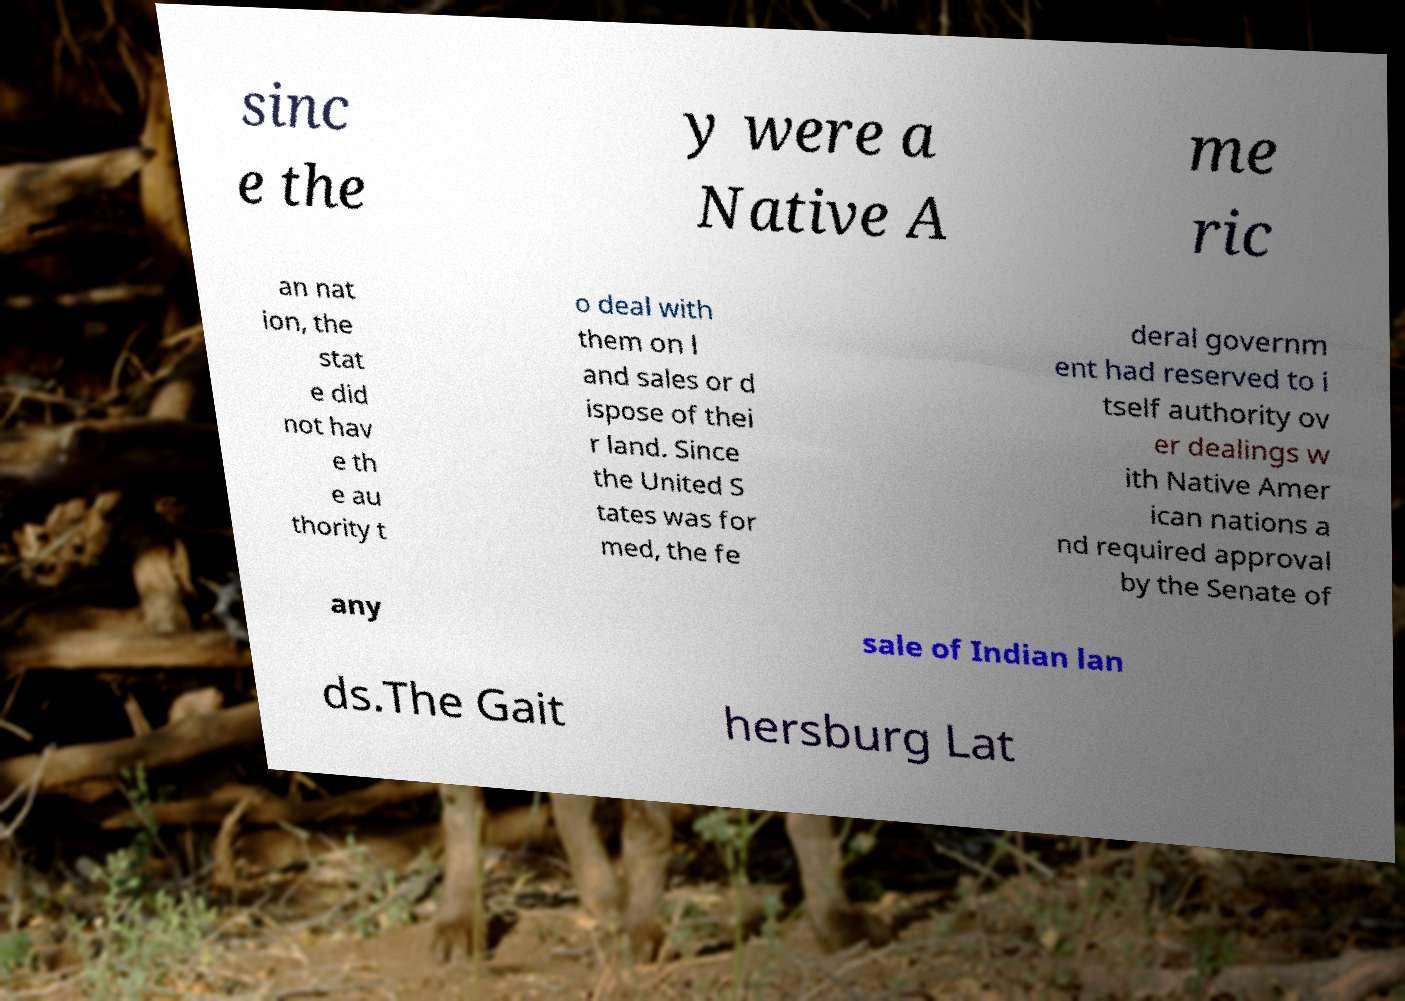Could you extract and type out the text from this image? sinc e the y were a Native A me ric an nat ion, the stat e did not hav e th e au thority t o deal with them on l and sales or d ispose of thei r land. Since the United S tates was for med, the fe deral governm ent had reserved to i tself authority ov er dealings w ith Native Amer ican nations a nd required approval by the Senate of any sale of Indian lan ds.The Gait hersburg Lat 